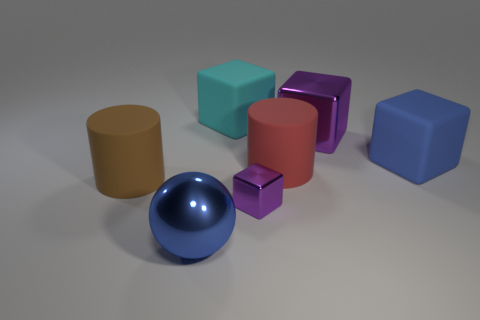Is the color of the metallic ball the same as the big matte block that is to the right of the big cyan cube?
Your answer should be compact. Yes. Is the color of the tiny thing that is to the left of the big red cylinder the same as the big shiny cube?
Keep it short and to the point. Yes. What number of other things are the same color as the small shiny cube?
Give a very brief answer. 1. Are there more cyan objects left of the large shiny block than gray rubber blocks?
Offer a very short reply. Yes. Is the color of the small shiny thing the same as the big shiny cube?
Your answer should be very brief. Yes. How many purple metallic things are the same shape as the cyan matte thing?
Provide a short and direct response. 2. What size is the red object that is the same material as the blue block?
Offer a terse response. Large. What is the color of the block that is both in front of the big purple block and on the right side of the tiny thing?
Ensure brevity in your answer.  Blue. What number of cyan matte objects have the same size as the brown matte cylinder?
Your response must be concise. 1. There is a thing that is the same color as the big shiny block; what is its size?
Your response must be concise. Small. 